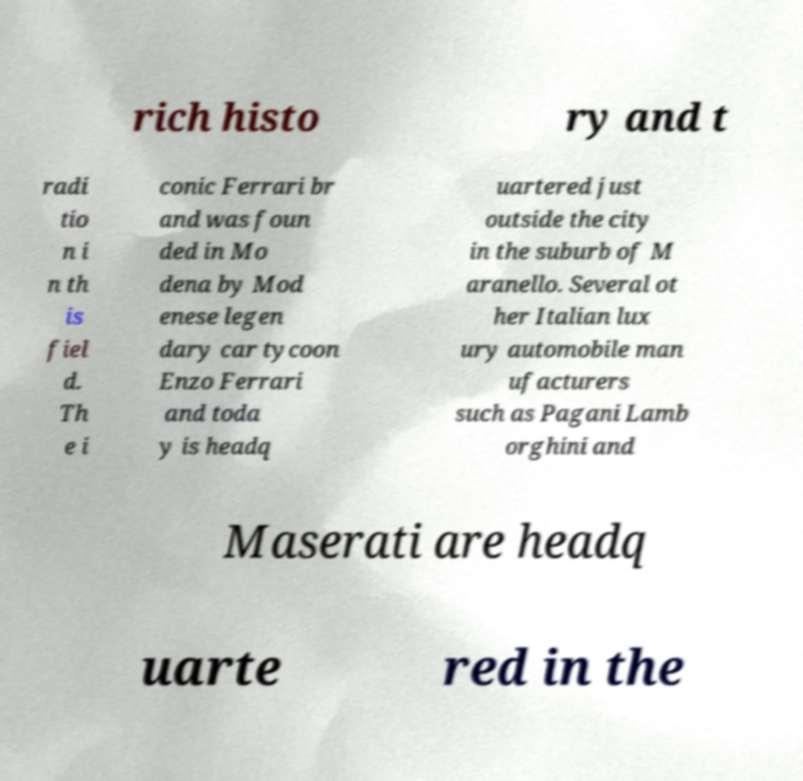There's text embedded in this image that I need extracted. Can you transcribe it verbatim? rich histo ry and t radi tio n i n th is fiel d. Th e i conic Ferrari br and was foun ded in Mo dena by Mod enese legen dary car tycoon Enzo Ferrari and toda y is headq uartered just outside the city in the suburb of M aranello. Several ot her Italian lux ury automobile man ufacturers such as Pagani Lamb orghini and Maserati are headq uarte red in the 